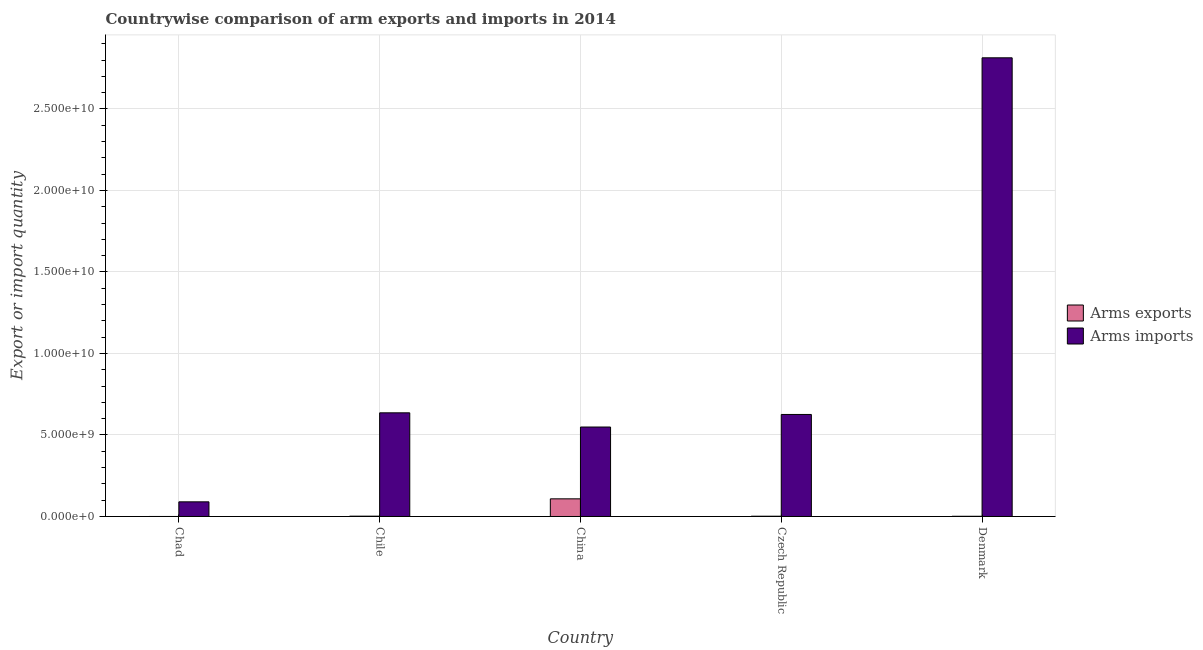How many different coloured bars are there?
Provide a short and direct response. 2. Are the number of bars on each tick of the X-axis equal?
Your answer should be compact. Yes. What is the label of the 1st group of bars from the left?
Your answer should be very brief. Chad. In how many cases, is the number of bars for a given country not equal to the number of legend labels?
Give a very brief answer. 0. What is the arms exports in Chad?
Provide a succinct answer. 1.00e+06. Across all countries, what is the maximum arms imports?
Offer a terse response. 2.81e+1. Across all countries, what is the minimum arms exports?
Ensure brevity in your answer.  1.00e+06. In which country was the arms exports minimum?
Offer a very short reply. Chad. What is the total arms exports in the graph?
Your answer should be very brief. 1.13e+09. What is the difference between the arms exports in Chile and that in China?
Give a very brief answer. -1.06e+09. What is the difference between the arms imports in China and the arms exports in Chad?
Ensure brevity in your answer.  5.49e+09. What is the average arms imports per country?
Your answer should be compact. 9.43e+09. What is the difference between the arms imports and arms exports in China?
Give a very brief answer. 4.41e+09. Is the arms exports in Chad less than that in Chile?
Your answer should be very brief. Yes. Is the difference between the arms imports in Chad and China greater than the difference between the arms exports in Chad and China?
Your answer should be compact. No. What is the difference between the highest and the second highest arms exports?
Offer a terse response. 1.06e+09. What is the difference between the highest and the lowest arms imports?
Your answer should be very brief. 2.72e+1. In how many countries, is the arms exports greater than the average arms exports taken over all countries?
Provide a short and direct response. 1. What does the 2nd bar from the left in Czech Republic represents?
Make the answer very short. Arms imports. What does the 2nd bar from the right in Czech Republic represents?
Make the answer very short. Arms exports. How many bars are there?
Your answer should be compact. 10. How many countries are there in the graph?
Offer a terse response. 5. What is the difference between two consecutive major ticks on the Y-axis?
Your answer should be very brief. 5.00e+09. Are the values on the major ticks of Y-axis written in scientific E-notation?
Ensure brevity in your answer.  Yes. How are the legend labels stacked?
Give a very brief answer. Vertical. What is the title of the graph?
Your response must be concise. Countrywise comparison of arm exports and imports in 2014. Does "Underweight" appear as one of the legend labels in the graph?
Your answer should be compact. No. What is the label or title of the X-axis?
Provide a succinct answer. Country. What is the label or title of the Y-axis?
Your answer should be compact. Export or import quantity. What is the Export or import quantity of Arms imports in Chad?
Ensure brevity in your answer.  8.99e+08. What is the Export or import quantity of Arms exports in Chile?
Offer a very short reply. 2.00e+07. What is the Export or import quantity in Arms imports in Chile?
Your answer should be compact. 6.36e+09. What is the Export or import quantity in Arms exports in China?
Provide a succinct answer. 1.08e+09. What is the Export or import quantity in Arms imports in China?
Make the answer very short. 5.49e+09. What is the Export or import quantity of Arms exports in Czech Republic?
Give a very brief answer. 1.70e+07. What is the Export or import quantity of Arms imports in Czech Republic?
Offer a very short reply. 6.26e+09. What is the Export or import quantity in Arms exports in Denmark?
Ensure brevity in your answer.  1.30e+07. What is the Export or import quantity in Arms imports in Denmark?
Offer a very short reply. 2.81e+1. Across all countries, what is the maximum Export or import quantity of Arms exports?
Your response must be concise. 1.08e+09. Across all countries, what is the maximum Export or import quantity of Arms imports?
Your answer should be compact. 2.81e+1. Across all countries, what is the minimum Export or import quantity of Arms exports?
Offer a very short reply. 1.00e+06. Across all countries, what is the minimum Export or import quantity of Arms imports?
Your answer should be very brief. 8.99e+08. What is the total Export or import quantity in Arms exports in the graph?
Offer a very short reply. 1.13e+09. What is the total Export or import quantity of Arms imports in the graph?
Keep it short and to the point. 4.71e+1. What is the difference between the Export or import quantity in Arms exports in Chad and that in Chile?
Give a very brief answer. -1.90e+07. What is the difference between the Export or import quantity in Arms imports in Chad and that in Chile?
Offer a terse response. -5.46e+09. What is the difference between the Export or import quantity in Arms exports in Chad and that in China?
Offer a very short reply. -1.08e+09. What is the difference between the Export or import quantity in Arms imports in Chad and that in China?
Give a very brief answer. -4.59e+09. What is the difference between the Export or import quantity in Arms exports in Chad and that in Czech Republic?
Your answer should be compact. -1.60e+07. What is the difference between the Export or import quantity of Arms imports in Chad and that in Czech Republic?
Keep it short and to the point. -5.36e+09. What is the difference between the Export or import quantity of Arms exports in Chad and that in Denmark?
Provide a succinct answer. -1.20e+07. What is the difference between the Export or import quantity of Arms imports in Chad and that in Denmark?
Your response must be concise. -2.72e+1. What is the difference between the Export or import quantity of Arms exports in Chile and that in China?
Your answer should be very brief. -1.06e+09. What is the difference between the Export or import quantity in Arms imports in Chile and that in China?
Your response must be concise. 8.71e+08. What is the difference between the Export or import quantity of Arms exports in Chile and that in Czech Republic?
Keep it short and to the point. 3.00e+06. What is the difference between the Export or import quantity of Arms imports in Chile and that in Czech Republic?
Provide a short and direct response. 1.01e+08. What is the difference between the Export or import quantity in Arms exports in Chile and that in Denmark?
Your response must be concise. 7.00e+06. What is the difference between the Export or import quantity of Arms imports in Chile and that in Denmark?
Your answer should be very brief. -2.18e+1. What is the difference between the Export or import quantity in Arms exports in China and that in Czech Republic?
Offer a very short reply. 1.07e+09. What is the difference between the Export or import quantity in Arms imports in China and that in Czech Republic?
Keep it short and to the point. -7.70e+08. What is the difference between the Export or import quantity of Arms exports in China and that in Denmark?
Keep it short and to the point. 1.07e+09. What is the difference between the Export or import quantity of Arms imports in China and that in Denmark?
Your answer should be very brief. -2.27e+1. What is the difference between the Export or import quantity in Arms imports in Czech Republic and that in Denmark?
Offer a terse response. -2.19e+1. What is the difference between the Export or import quantity in Arms exports in Chad and the Export or import quantity in Arms imports in Chile?
Ensure brevity in your answer.  -6.36e+09. What is the difference between the Export or import quantity of Arms exports in Chad and the Export or import quantity of Arms imports in China?
Offer a terse response. -5.49e+09. What is the difference between the Export or import quantity in Arms exports in Chad and the Export or import quantity in Arms imports in Czech Republic?
Provide a short and direct response. -6.26e+09. What is the difference between the Export or import quantity of Arms exports in Chad and the Export or import quantity of Arms imports in Denmark?
Give a very brief answer. -2.81e+1. What is the difference between the Export or import quantity in Arms exports in Chile and the Export or import quantity in Arms imports in China?
Provide a succinct answer. -5.47e+09. What is the difference between the Export or import quantity of Arms exports in Chile and the Export or import quantity of Arms imports in Czech Republic?
Provide a succinct answer. -6.24e+09. What is the difference between the Export or import quantity of Arms exports in Chile and the Export or import quantity of Arms imports in Denmark?
Your response must be concise. -2.81e+1. What is the difference between the Export or import quantity of Arms exports in China and the Export or import quantity of Arms imports in Czech Republic?
Offer a very short reply. -5.18e+09. What is the difference between the Export or import quantity of Arms exports in China and the Export or import quantity of Arms imports in Denmark?
Offer a terse response. -2.71e+1. What is the difference between the Export or import quantity of Arms exports in Czech Republic and the Export or import quantity of Arms imports in Denmark?
Provide a short and direct response. -2.81e+1. What is the average Export or import quantity in Arms exports per country?
Provide a succinct answer. 2.27e+08. What is the average Export or import quantity of Arms imports per country?
Provide a succinct answer. 9.43e+09. What is the difference between the Export or import quantity in Arms exports and Export or import quantity in Arms imports in Chad?
Ensure brevity in your answer.  -8.98e+08. What is the difference between the Export or import quantity of Arms exports and Export or import quantity of Arms imports in Chile?
Offer a very short reply. -6.34e+09. What is the difference between the Export or import quantity of Arms exports and Export or import quantity of Arms imports in China?
Give a very brief answer. -4.41e+09. What is the difference between the Export or import quantity in Arms exports and Export or import quantity in Arms imports in Czech Republic?
Your answer should be compact. -6.24e+09. What is the difference between the Export or import quantity of Arms exports and Export or import quantity of Arms imports in Denmark?
Provide a short and direct response. -2.81e+1. What is the ratio of the Export or import quantity of Arms exports in Chad to that in Chile?
Give a very brief answer. 0.05. What is the ratio of the Export or import quantity in Arms imports in Chad to that in Chile?
Ensure brevity in your answer.  0.14. What is the ratio of the Export or import quantity in Arms exports in Chad to that in China?
Ensure brevity in your answer.  0. What is the ratio of the Export or import quantity in Arms imports in Chad to that in China?
Provide a short and direct response. 0.16. What is the ratio of the Export or import quantity of Arms exports in Chad to that in Czech Republic?
Give a very brief answer. 0.06. What is the ratio of the Export or import quantity of Arms imports in Chad to that in Czech Republic?
Your response must be concise. 0.14. What is the ratio of the Export or import quantity of Arms exports in Chad to that in Denmark?
Give a very brief answer. 0.08. What is the ratio of the Export or import quantity of Arms imports in Chad to that in Denmark?
Offer a very short reply. 0.03. What is the ratio of the Export or import quantity of Arms exports in Chile to that in China?
Give a very brief answer. 0.02. What is the ratio of the Export or import quantity of Arms imports in Chile to that in China?
Ensure brevity in your answer.  1.16. What is the ratio of the Export or import quantity of Arms exports in Chile to that in Czech Republic?
Offer a very short reply. 1.18. What is the ratio of the Export or import quantity of Arms imports in Chile to that in Czech Republic?
Provide a succinct answer. 1.02. What is the ratio of the Export or import quantity in Arms exports in Chile to that in Denmark?
Make the answer very short. 1.54. What is the ratio of the Export or import quantity of Arms imports in Chile to that in Denmark?
Provide a succinct answer. 0.23. What is the ratio of the Export or import quantity of Arms exports in China to that in Czech Republic?
Provide a short and direct response. 63.71. What is the ratio of the Export or import quantity of Arms imports in China to that in Czech Republic?
Offer a very short reply. 0.88. What is the ratio of the Export or import quantity in Arms exports in China to that in Denmark?
Your answer should be very brief. 83.31. What is the ratio of the Export or import quantity in Arms imports in China to that in Denmark?
Offer a terse response. 0.2. What is the ratio of the Export or import quantity in Arms exports in Czech Republic to that in Denmark?
Your response must be concise. 1.31. What is the ratio of the Export or import quantity of Arms imports in Czech Republic to that in Denmark?
Ensure brevity in your answer.  0.22. What is the difference between the highest and the second highest Export or import quantity of Arms exports?
Ensure brevity in your answer.  1.06e+09. What is the difference between the highest and the second highest Export or import quantity in Arms imports?
Your answer should be compact. 2.18e+1. What is the difference between the highest and the lowest Export or import quantity of Arms exports?
Offer a terse response. 1.08e+09. What is the difference between the highest and the lowest Export or import quantity of Arms imports?
Ensure brevity in your answer.  2.72e+1. 